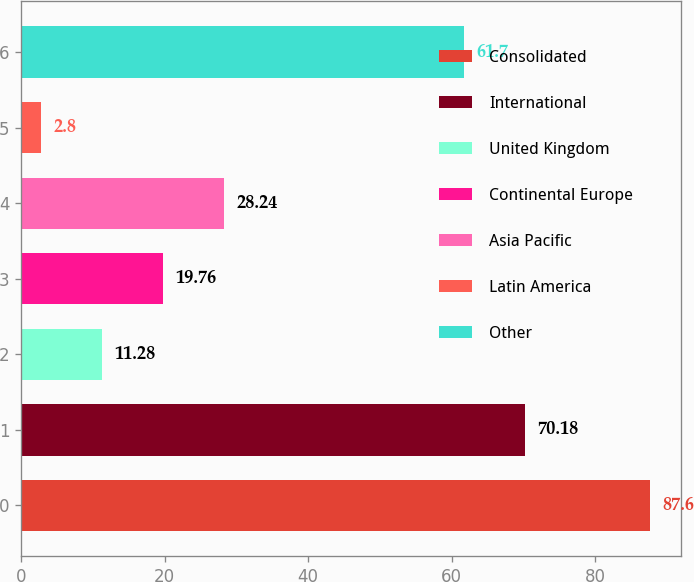<chart> <loc_0><loc_0><loc_500><loc_500><bar_chart><fcel>Consolidated<fcel>International<fcel>United Kingdom<fcel>Continental Europe<fcel>Asia Pacific<fcel>Latin America<fcel>Other<nl><fcel>87.6<fcel>70.18<fcel>11.28<fcel>19.76<fcel>28.24<fcel>2.8<fcel>61.7<nl></chart> 